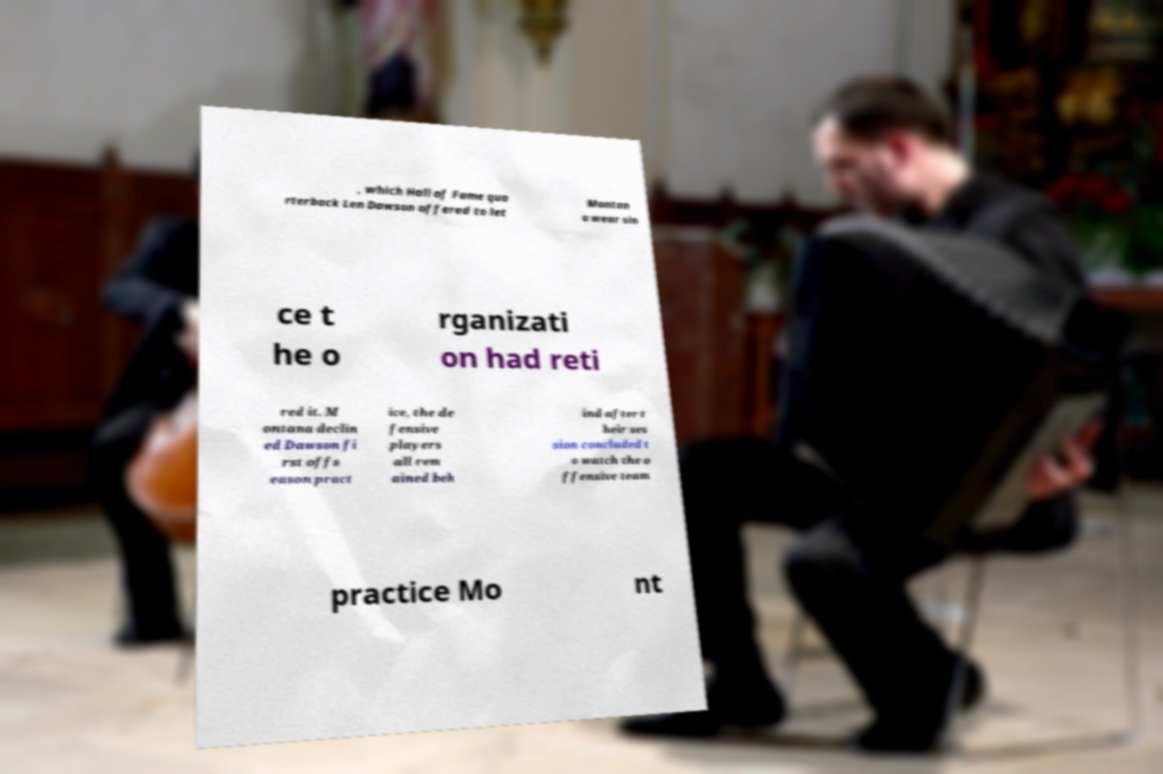Could you assist in decoding the text presented in this image and type it out clearly? , which Hall of Fame qua rterback Len Dawson offered to let Montan a wear sin ce t he o rganizati on had reti red it. M ontana declin ed Dawson fi rst offs eason pract ice, the de fensive players all rem ained beh ind after t heir ses sion concluded t o watch the o ffensive team practice Mo nt 